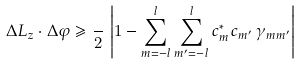<formula> <loc_0><loc_0><loc_500><loc_500>\Delta L _ { z } \cdot \Delta \varphi \geqslant \frac { } { 2 } \, \left | 1 - \sum _ { m = - l } ^ { l } \sum _ { m ^ { \prime } = - l } ^ { l } c _ { m } ^ { * } c _ { m ^ { \prime } } \, \gamma _ { m m ^ { \prime } } \right |</formula> 